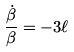Convert formula to latex. <formula><loc_0><loc_0><loc_500><loc_500>\frac { \dot { \beta } } { \beta } = - 3 \ell</formula> 